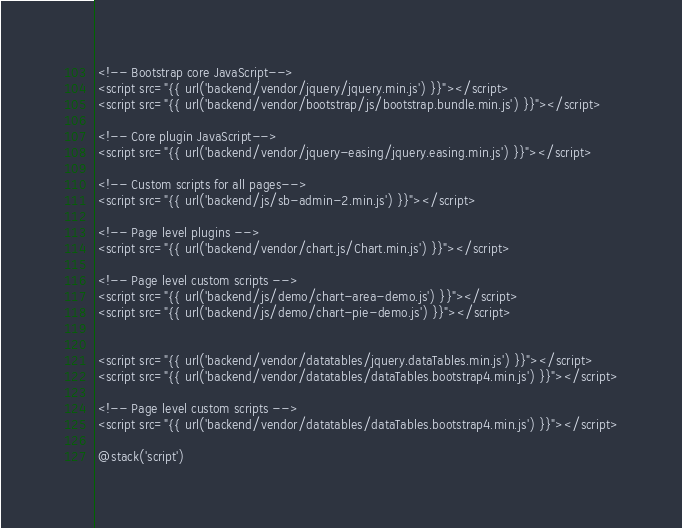<code> <loc_0><loc_0><loc_500><loc_500><_PHP_> <!-- Bootstrap core JavaScript-->
 <script src="{{ url('backend/vendor/jquery/jquery.min.js') }}"></script>
 <script src="{{ url('backend/vendor/bootstrap/js/bootstrap.bundle.min.js') }}"></script>

 <!-- Core plugin JavaScript-->
 <script src="{{ url('backend/vendor/jquery-easing/jquery.easing.min.js') }}"></script>

 <!-- Custom scripts for all pages-->
 <script src="{{ url('backend/js/sb-admin-2.min.js') }}"></script>

 <!-- Page level plugins -->
 <script src="{{ url('backend/vendor/chart.js/Chart.min.js') }}"></script>

 <!-- Page level custom scripts -->
 <script src="{{ url('backend/js/demo/chart-area-demo.js') }}"></script>
 <script src="{{ url('backend/js/demo/chart-pie-demo.js') }}"></script>


 <script src="{{ url('backend/vendor/datatables/jquery.dataTables.min.js') }}"></script>
 <script src="{{ url('backend/vendor/datatables/dataTables.bootstrap4.min.js') }}"></script>

 <!-- Page level custom scripts -->
 <script src="{{ url('backend/vendor/datatables/dataTables.bootstrap4.min.js') }}"></script>

 @stack('script')
</code> 